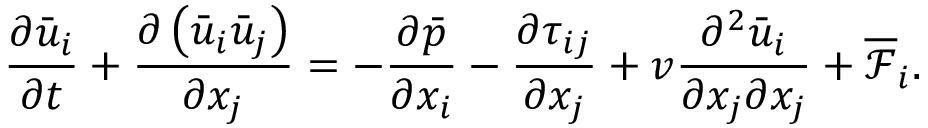Convert formula to latex. <formula><loc_0><loc_0><loc_500><loc_500>\frac { \partial \bar { u } _ { i } } { \partial t } + \frac { \partial \left ( \bar { u } _ { i } \bar { u } _ { j } \right ) } { \partial x _ { j } } = - \frac { \partial \bar { p } } { \partial x _ { i } } - \frac { \partial \tau _ { i j } } { \partial x _ { j } } + v \frac { \partial ^ { 2 } \bar { u } _ { i } } { \partial x _ { j } \partial x _ { j } } + \overline { { \mathcal { F } } } _ { i } .</formula> 